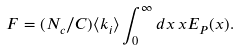<formula> <loc_0><loc_0><loc_500><loc_500>F = ( N _ { c } / C ) \langle k _ { i } \rangle \int _ { 0 } ^ { \infty } d x \, x E _ { P } ( x ) .</formula> 